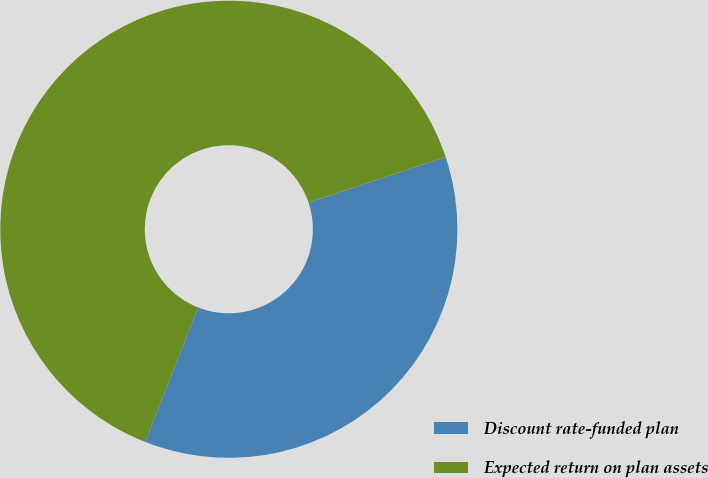Convert chart to OTSL. <chart><loc_0><loc_0><loc_500><loc_500><pie_chart><fcel>Discount rate-funded plan<fcel>Expected return on plan assets<nl><fcel>36.07%<fcel>63.93%<nl></chart> 